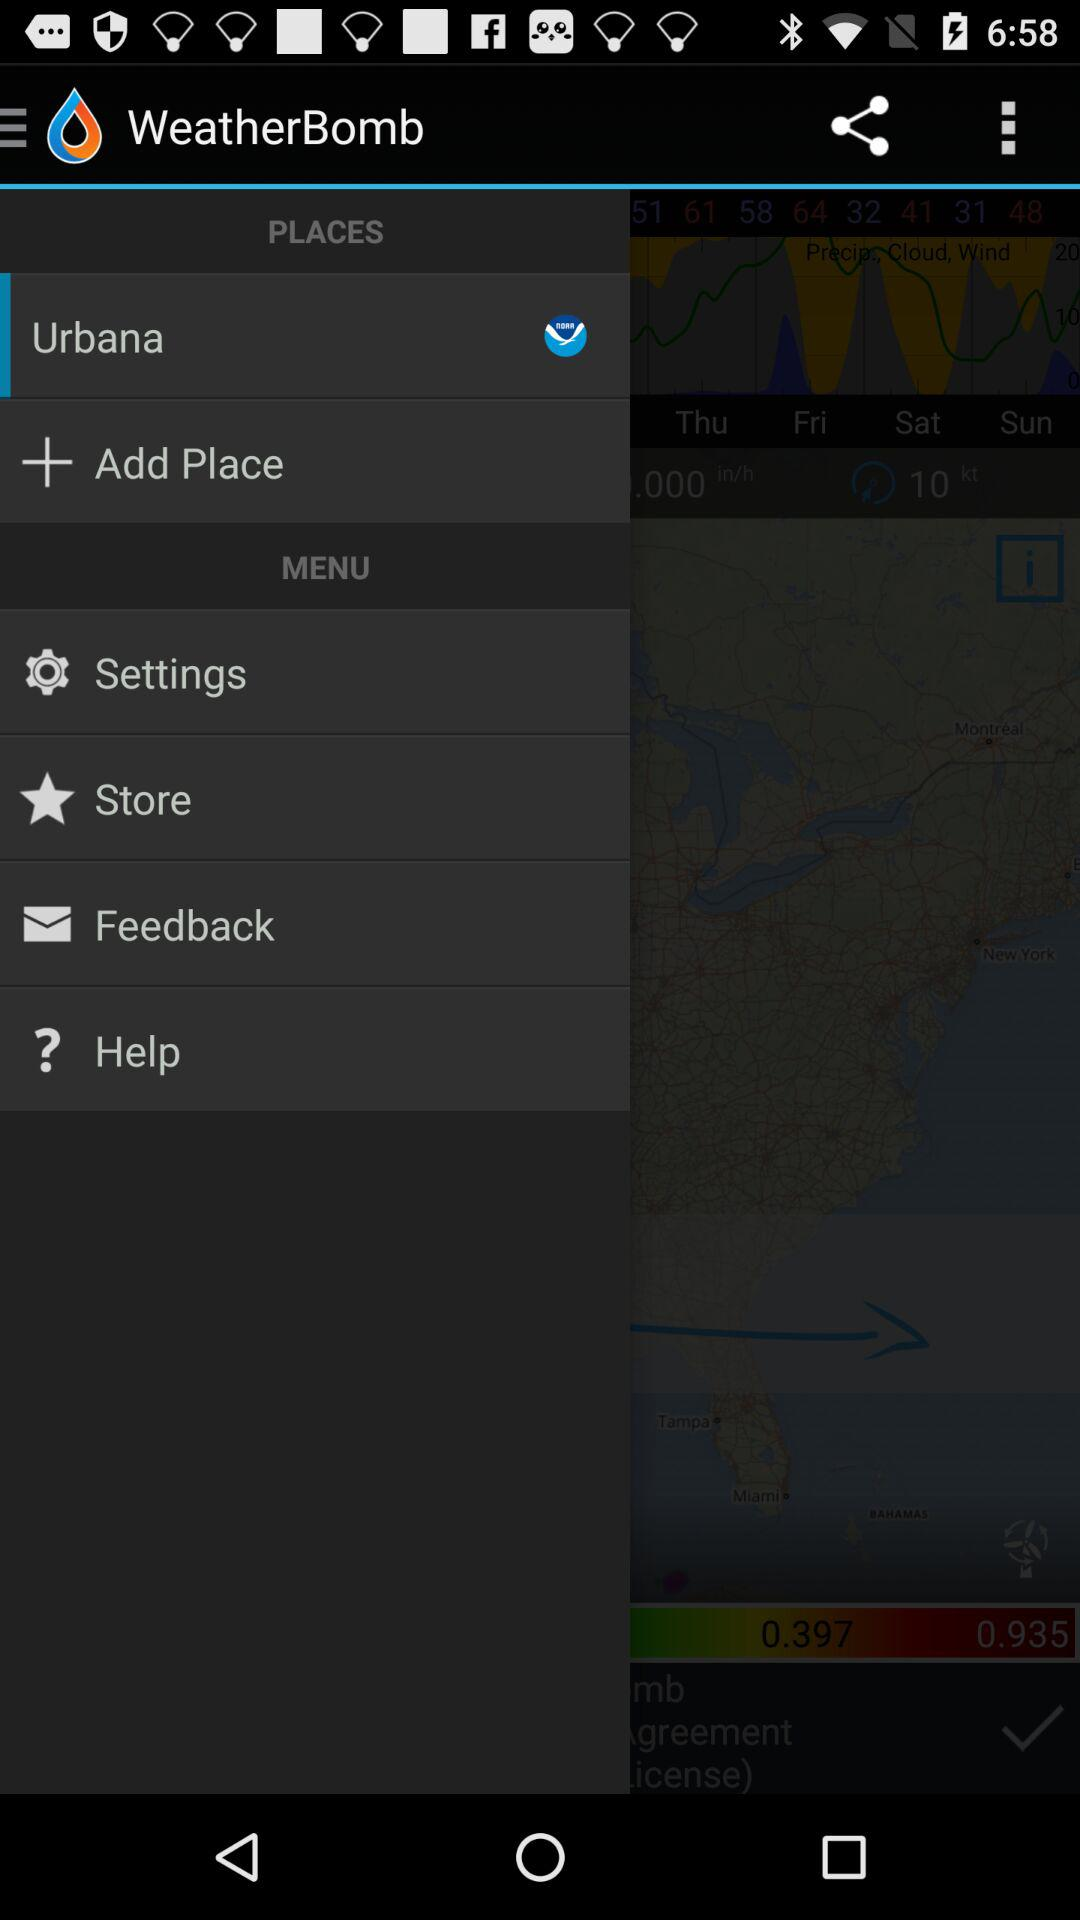What is the name of the application? The name of the application is "WeatherBomb". 